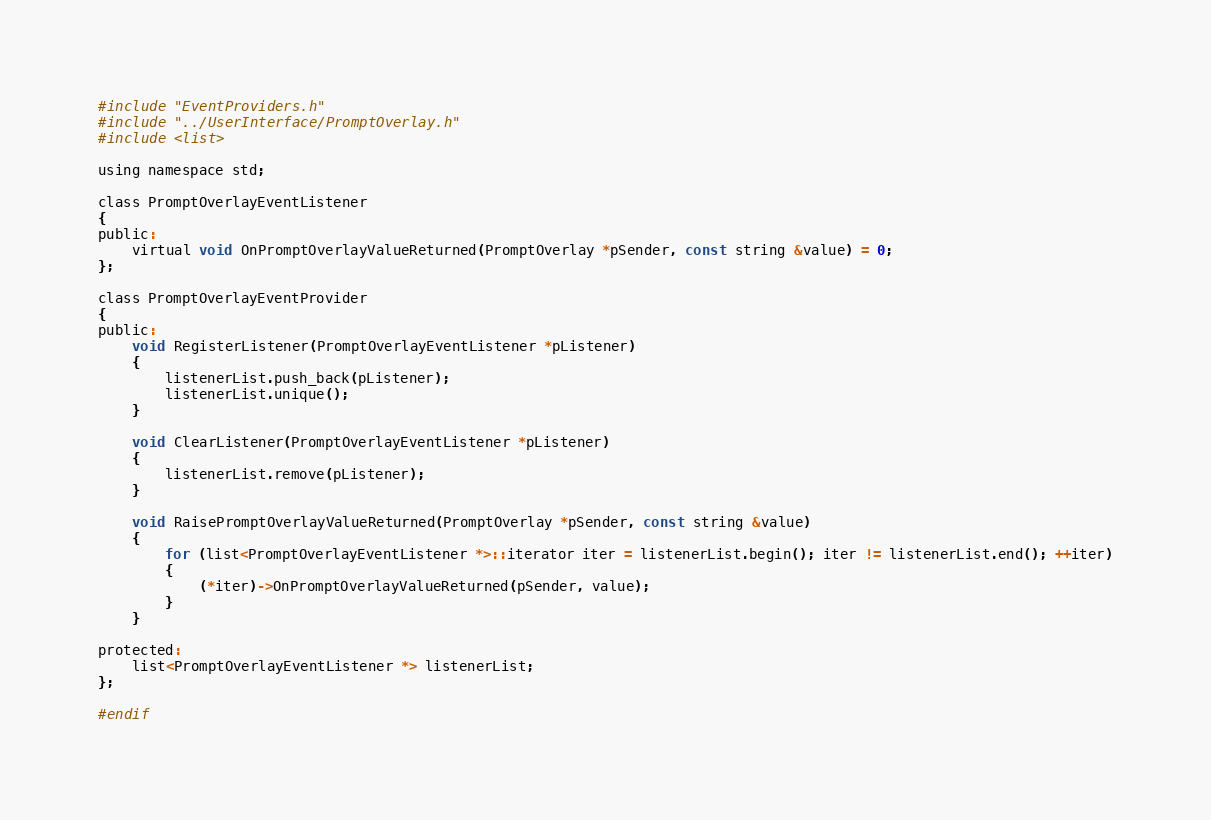Convert code to text. <code><loc_0><loc_0><loc_500><loc_500><_C_>
#include "EventProviders.h"
#include "../UserInterface/PromptOverlay.h"
#include <list>

using namespace std;

class PromptOverlayEventListener
{
public:
    virtual void OnPromptOverlayValueReturned(PromptOverlay *pSender, const string &value) = 0;
};

class PromptOverlayEventProvider
{
public:
    void RegisterListener(PromptOverlayEventListener *pListener)
    {
        listenerList.push_back(pListener);
        listenerList.unique();
    }

    void ClearListener(PromptOverlayEventListener *pListener)
    {
        listenerList.remove(pListener);
    }

    void RaisePromptOverlayValueReturned(PromptOverlay *pSender, const string &value)
    {
        for (list<PromptOverlayEventListener *>::iterator iter = listenerList.begin(); iter != listenerList.end(); ++iter)
        {
            (*iter)->OnPromptOverlayValueReturned(pSender, value);
        }
    }

protected:
    list<PromptOverlayEventListener *> listenerList;
};

#endif
</code> 